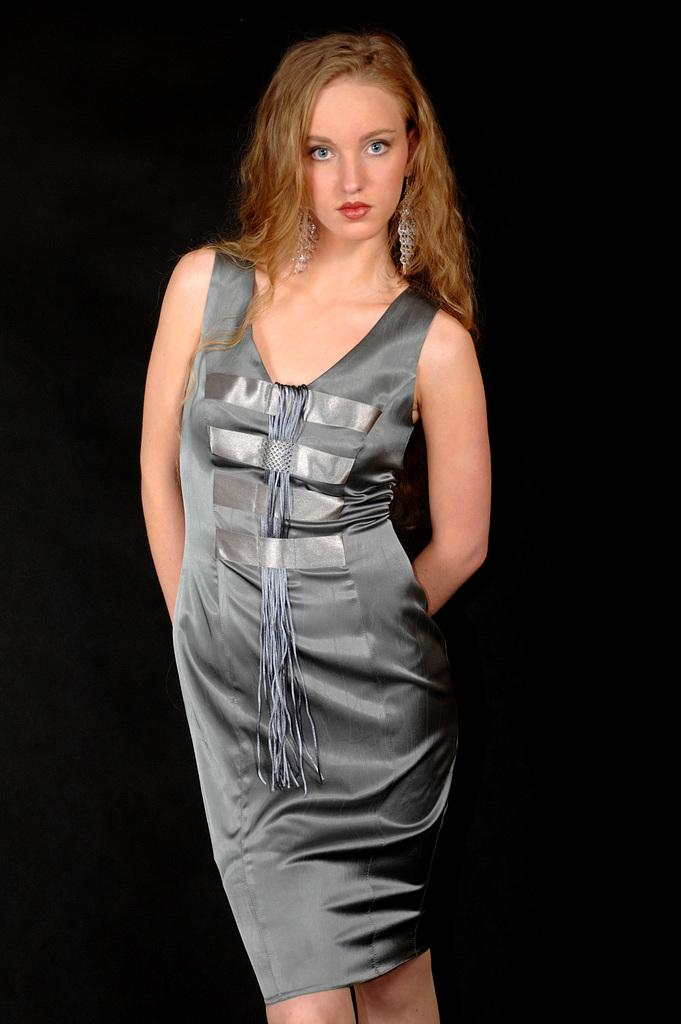Who is the main subject in the image? There is a woman in the image. What is the woman doing in the image? The woman is standing and watching. What type of vase is the woman holding in the image? There is no vase present in the image; the woman is simply standing and watching. 